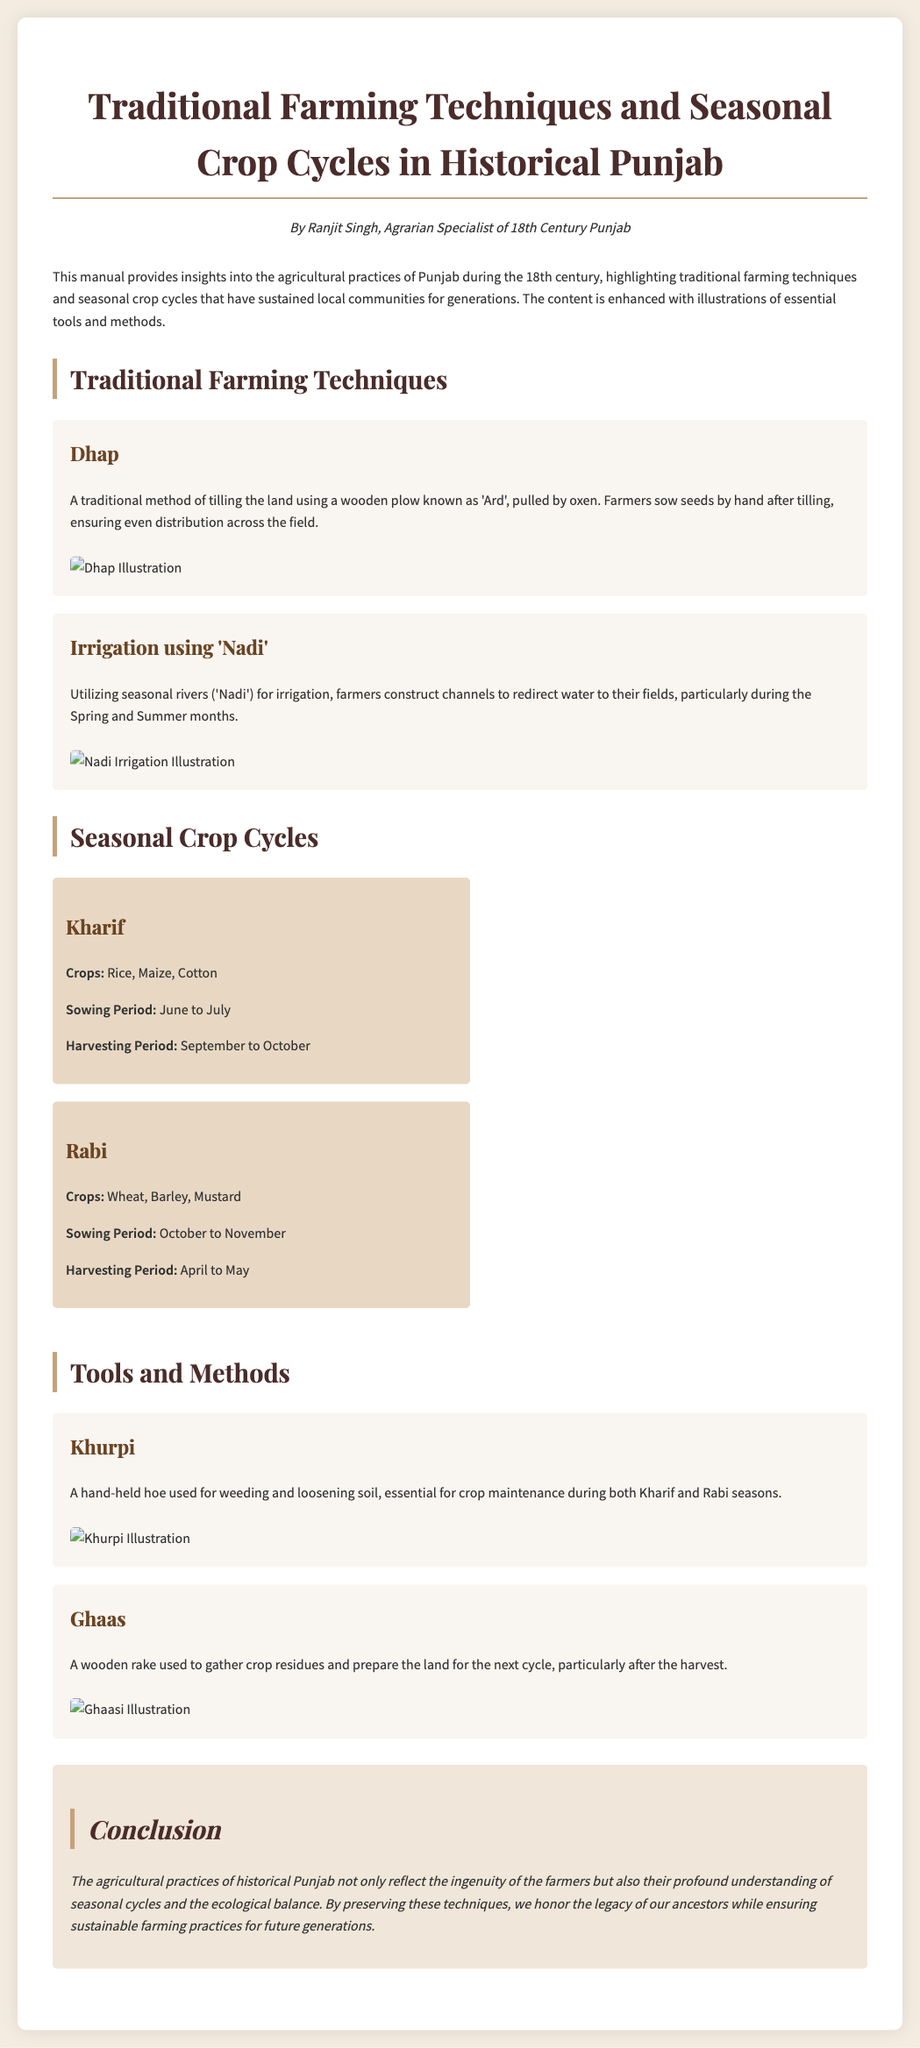What is the title of the manual? The title is the main heading presented at the top of the document.
Answer: Traditional Farming Techniques and Seasonal Crop Cycles in Historical Punjab Who is the author of the manual? The author is mentioned under the title, providing the name and title of the person who wrote it.
Answer: Ranjit Singh What crops are included in the Kharif season? This information is stated in the seasonal crop cycle section for Kharif, listing specific crops.
Answer: Rice, Maize, Cotton What is the sowing period for Rabi crops? The document explicitly states the time frame for sowing Rabi crops in the seasonal crop cycle section.
Answer: October to November What tool is described as a hand-held hoe? The specific tool is mentioned in the tools and methods section, indicating its use.
Answer: Khurpi How do farmers irrigate their fields during the Spring and Summer months? The method used for irrigation during these months is detailed in the traditional farming techniques section, referring to a specific natural resource.
Answer: Nadi In which months is the harvesting period for Kharif crops? The harvesting period is clearly outlined in the seasonal crop cycle section, providing specific months.
Answer: September to October What agricultural method involves using a wooden plow called 'Ard'? This traditional farming technique is described in the manual, emphasizing its usage for tilling.
Answer: Dhap What is the main purpose of the tool 'Ghaas'? The document describes this tool's function within the tools and methods section, indicating its role after harvesting.
Answer: Gather crop residues 